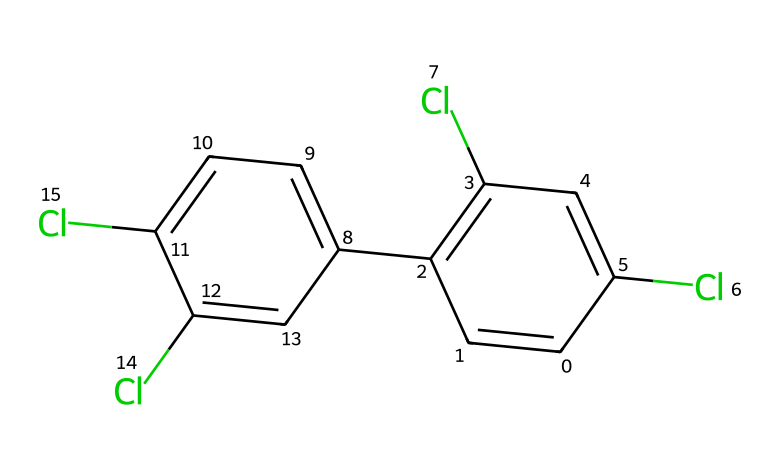What is the name of this chemical? The SMILES representation reveals the structure of the chemical with multiple chlorine substituents on aromatic rings. This matches the chemical name "polychlorinated biphenyls" (PCBs).
Answer: polychlorinated biphenyls How many chlorine atoms are in this chemical? By analyzing the SMILES representation, we can count the chlorine atoms represented by "Cl" in the structure. There are four "Cl" symbols present.
Answer: four What is the total number of carbon atoms in this chemical? The SMILES structure consists of various "c" and "cc" notations, indicating carbon atoms in the aromatic rings. Counting these, we find there are twelve carbon atoms in total.
Answer: twelve What type of compound is this? The structure reveals multiple aromatic rings with chlorine substitutions, classifying this compound as an aromatic compound, specifically a polycyclic aromatic compound due to its multiple interconnected rings.
Answer: aromatic compound What is a common property of polychlorinated biphenyls? Polychlorinated biphenyls are known to be persistent organic pollutants. This refers to their stability and resistance to environmental degradation, allowing them to accumulate in the environment and living organisms.
Answer: persistent organic pollutants Why are PCBs considered harmful? PCBs have significant ecological implications due to their persistence and bioaccumulation in the food chain, leading to adverse effects on wildlife and human health by disrupting endocrine systems and causing developmental issues.
Answer: ecological implications 